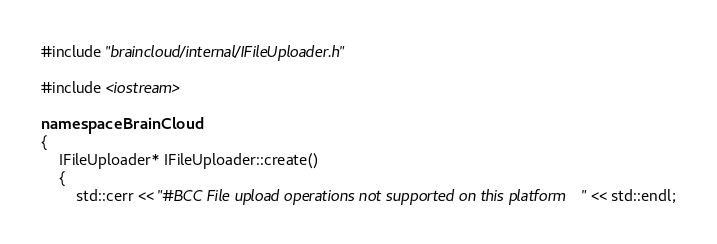<code> <loc_0><loc_0><loc_500><loc_500><_C++_>#include "braincloud/internal/IFileUploader.h"

#include <iostream>

namespace BrainCloud
{
    IFileUploader* IFileUploader::create()
    {
        std::cerr << "#BCC File upload operations not supported on this platform" << std::endl;</code> 